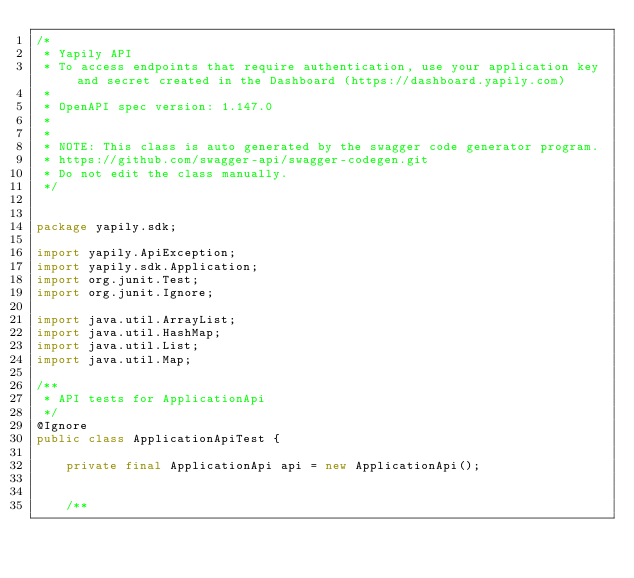Convert code to text. <code><loc_0><loc_0><loc_500><loc_500><_Java_>/*
 * Yapily API
 * To access endpoints that require authentication, use your application key and secret created in the Dashboard (https://dashboard.yapily.com)
 *
 * OpenAPI spec version: 1.147.0
 * 
 *
 * NOTE: This class is auto generated by the swagger code generator program.
 * https://github.com/swagger-api/swagger-codegen.git
 * Do not edit the class manually.
 */


package yapily.sdk;

import yapily.ApiException;
import yapily.sdk.Application;
import org.junit.Test;
import org.junit.Ignore;

import java.util.ArrayList;
import java.util.HashMap;
import java.util.List;
import java.util.Map;

/**
 * API tests for ApplicationApi
 */
@Ignore
public class ApplicationApiTest {

    private final ApplicationApi api = new ApplicationApi();

    
    /**</code> 